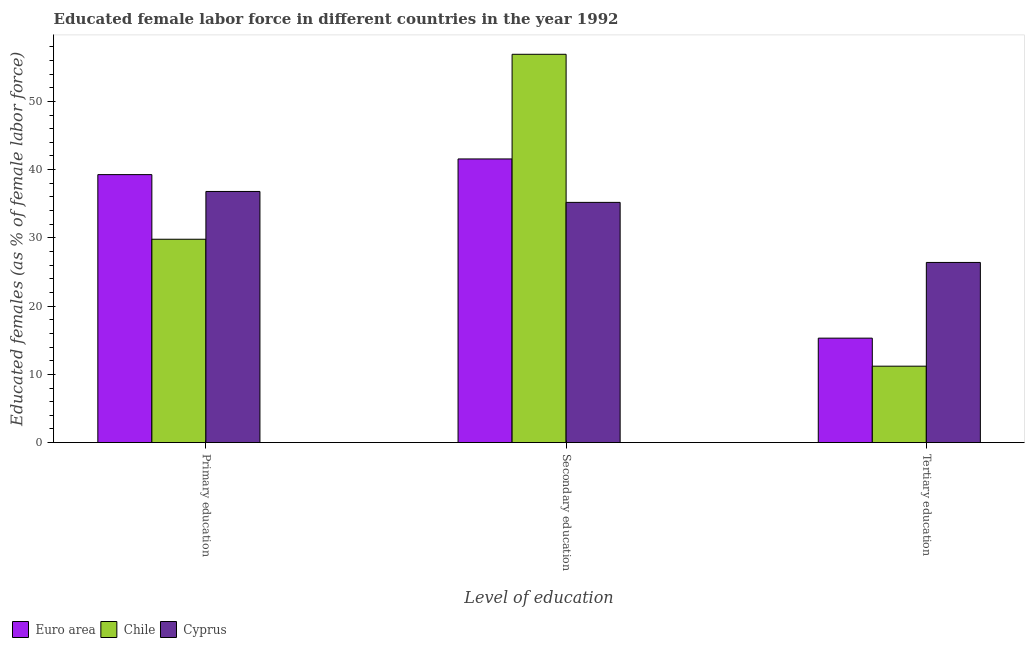How many different coloured bars are there?
Make the answer very short. 3. How many groups of bars are there?
Your answer should be compact. 3. Are the number of bars on each tick of the X-axis equal?
Your response must be concise. Yes. What is the label of the 1st group of bars from the left?
Provide a succinct answer. Primary education. What is the percentage of female labor force who received secondary education in Cyprus?
Ensure brevity in your answer.  35.2. Across all countries, what is the maximum percentage of female labor force who received secondary education?
Your answer should be very brief. 56.9. Across all countries, what is the minimum percentage of female labor force who received secondary education?
Provide a succinct answer. 35.2. What is the total percentage of female labor force who received secondary education in the graph?
Keep it short and to the point. 133.66. What is the difference between the percentage of female labor force who received secondary education in Cyprus and that in Chile?
Keep it short and to the point. -21.7. What is the difference between the percentage of female labor force who received secondary education in Cyprus and the percentage of female labor force who received tertiary education in Chile?
Provide a short and direct response. 24. What is the average percentage of female labor force who received tertiary education per country?
Your answer should be compact. 17.64. What is the difference between the percentage of female labor force who received primary education and percentage of female labor force who received secondary education in Cyprus?
Offer a terse response. 1.6. In how many countries, is the percentage of female labor force who received tertiary education greater than 12 %?
Provide a succinct answer. 2. What is the ratio of the percentage of female labor force who received secondary education in Euro area to that in Cyprus?
Keep it short and to the point. 1.18. Is the percentage of female labor force who received secondary education in Cyprus less than that in Euro area?
Your answer should be very brief. Yes. What is the difference between the highest and the second highest percentage of female labor force who received primary education?
Keep it short and to the point. 2.47. What is the difference between the highest and the lowest percentage of female labor force who received tertiary education?
Offer a very short reply. 15.2. In how many countries, is the percentage of female labor force who received tertiary education greater than the average percentage of female labor force who received tertiary education taken over all countries?
Your response must be concise. 1. What does the 3rd bar from the right in Tertiary education represents?
Provide a short and direct response. Euro area. How many bars are there?
Offer a terse response. 9. How many countries are there in the graph?
Ensure brevity in your answer.  3. What is the difference between two consecutive major ticks on the Y-axis?
Provide a succinct answer. 10. Does the graph contain grids?
Provide a short and direct response. No. How are the legend labels stacked?
Give a very brief answer. Horizontal. What is the title of the graph?
Give a very brief answer. Educated female labor force in different countries in the year 1992. Does "Bosnia and Herzegovina" appear as one of the legend labels in the graph?
Give a very brief answer. No. What is the label or title of the X-axis?
Give a very brief answer. Level of education. What is the label or title of the Y-axis?
Give a very brief answer. Educated females (as % of female labor force). What is the Educated females (as % of female labor force) in Euro area in Primary education?
Your response must be concise. 39.27. What is the Educated females (as % of female labor force) in Chile in Primary education?
Make the answer very short. 29.8. What is the Educated females (as % of female labor force) in Cyprus in Primary education?
Offer a terse response. 36.8. What is the Educated females (as % of female labor force) of Euro area in Secondary education?
Give a very brief answer. 41.56. What is the Educated females (as % of female labor force) of Chile in Secondary education?
Offer a very short reply. 56.9. What is the Educated females (as % of female labor force) of Cyprus in Secondary education?
Give a very brief answer. 35.2. What is the Educated females (as % of female labor force) of Euro area in Tertiary education?
Your answer should be compact. 15.31. What is the Educated females (as % of female labor force) in Chile in Tertiary education?
Your answer should be very brief. 11.2. What is the Educated females (as % of female labor force) of Cyprus in Tertiary education?
Your response must be concise. 26.4. Across all Level of education, what is the maximum Educated females (as % of female labor force) of Euro area?
Your answer should be compact. 41.56. Across all Level of education, what is the maximum Educated females (as % of female labor force) of Chile?
Make the answer very short. 56.9. Across all Level of education, what is the maximum Educated females (as % of female labor force) of Cyprus?
Ensure brevity in your answer.  36.8. Across all Level of education, what is the minimum Educated females (as % of female labor force) of Euro area?
Provide a succinct answer. 15.31. Across all Level of education, what is the minimum Educated females (as % of female labor force) in Chile?
Your response must be concise. 11.2. Across all Level of education, what is the minimum Educated females (as % of female labor force) in Cyprus?
Make the answer very short. 26.4. What is the total Educated females (as % of female labor force) in Euro area in the graph?
Provide a short and direct response. 96.14. What is the total Educated females (as % of female labor force) in Chile in the graph?
Provide a short and direct response. 97.9. What is the total Educated females (as % of female labor force) in Cyprus in the graph?
Provide a short and direct response. 98.4. What is the difference between the Educated females (as % of female labor force) of Euro area in Primary education and that in Secondary education?
Your answer should be compact. -2.3. What is the difference between the Educated females (as % of female labor force) of Chile in Primary education and that in Secondary education?
Your response must be concise. -27.1. What is the difference between the Educated females (as % of female labor force) in Euro area in Primary education and that in Tertiary education?
Ensure brevity in your answer.  23.96. What is the difference between the Educated females (as % of female labor force) in Chile in Primary education and that in Tertiary education?
Your answer should be very brief. 18.6. What is the difference between the Educated females (as % of female labor force) of Euro area in Secondary education and that in Tertiary education?
Provide a succinct answer. 26.26. What is the difference between the Educated females (as % of female labor force) in Chile in Secondary education and that in Tertiary education?
Keep it short and to the point. 45.7. What is the difference between the Educated females (as % of female labor force) in Euro area in Primary education and the Educated females (as % of female labor force) in Chile in Secondary education?
Provide a short and direct response. -17.63. What is the difference between the Educated females (as % of female labor force) of Euro area in Primary education and the Educated females (as % of female labor force) of Cyprus in Secondary education?
Offer a terse response. 4.07. What is the difference between the Educated females (as % of female labor force) in Chile in Primary education and the Educated females (as % of female labor force) in Cyprus in Secondary education?
Give a very brief answer. -5.4. What is the difference between the Educated females (as % of female labor force) of Euro area in Primary education and the Educated females (as % of female labor force) of Chile in Tertiary education?
Provide a succinct answer. 28.07. What is the difference between the Educated females (as % of female labor force) of Euro area in Primary education and the Educated females (as % of female labor force) of Cyprus in Tertiary education?
Your answer should be compact. 12.87. What is the difference between the Educated females (as % of female labor force) of Euro area in Secondary education and the Educated females (as % of female labor force) of Chile in Tertiary education?
Provide a short and direct response. 30.36. What is the difference between the Educated females (as % of female labor force) in Euro area in Secondary education and the Educated females (as % of female labor force) in Cyprus in Tertiary education?
Keep it short and to the point. 15.16. What is the difference between the Educated females (as % of female labor force) of Chile in Secondary education and the Educated females (as % of female labor force) of Cyprus in Tertiary education?
Offer a terse response. 30.5. What is the average Educated females (as % of female labor force) of Euro area per Level of education?
Offer a very short reply. 32.05. What is the average Educated females (as % of female labor force) of Chile per Level of education?
Offer a very short reply. 32.63. What is the average Educated females (as % of female labor force) of Cyprus per Level of education?
Provide a short and direct response. 32.8. What is the difference between the Educated females (as % of female labor force) of Euro area and Educated females (as % of female labor force) of Chile in Primary education?
Offer a terse response. 9.47. What is the difference between the Educated females (as % of female labor force) in Euro area and Educated females (as % of female labor force) in Cyprus in Primary education?
Offer a very short reply. 2.47. What is the difference between the Educated females (as % of female labor force) in Chile and Educated females (as % of female labor force) in Cyprus in Primary education?
Provide a succinct answer. -7. What is the difference between the Educated females (as % of female labor force) of Euro area and Educated females (as % of female labor force) of Chile in Secondary education?
Make the answer very short. -15.34. What is the difference between the Educated females (as % of female labor force) of Euro area and Educated females (as % of female labor force) of Cyprus in Secondary education?
Your answer should be compact. 6.36. What is the difference between the Educated females (as % of female labor force) in Chile and Educated females (as % of female labor force) in Cyprus in Secondary education?
Provide a short and direct response. 21.7. What is the difference between the Educated females (as % of female labor force) of Euro area and Educated females (as % of female labor force) of Chile in Tertiary education?
Make the answer very short. 4.11. What is the difference between the Educated females (as % of female labor force) in Euro area and Educated females (as % of female labor force) in Cyprus in Tertiary education?
Provide a short and direct response. -11.09. What is the difference between the Educated females (as % of female labor force) in Chile and Educated females (as % of female labor force) in Cyprus in Tertiary education?
Your answer should be compact. -15.2. What is the ratio of the Educated females (as % of female labor force) in Euro area in Primary education to that in Secondary education?
Keep it short and to the point. 0.94. What is the ratio of the Educated females (as % of female labor force) in Chile in Primary education to that in Secondary education?
Your answer should be very brief. 0.52. What is the ratio of the Educated females (as % of female labor force) of Cyprus in Primary education to that in Secondary education?
Your answer should be very brief. 1.05. What is the ratio of the Educated females (as % of female labor force) of Euro area in Primary education to that in Tertiary education?
Provide a succinct answer. 2.57. What is the ratio of the Educated females (as % of female labor force) of Chile in Primary education to that in Tertiary education?
Offer a very short reply. 2.66. What is the ratio of the Educated females (as % of female labor force) in Cyprus in Primary education to that in Tertiary education?
Your answer should be very brief. 1.39. What is the ratio of the Educated females (as % of female labor force) of Euro area in Secondary education to that in Tertiary education?
Your answer should be very brief. 2.72. What is the ratio of the Educated females (as % of female labor force) in Chile in Secondary education to that in Tertiary education?
Give a very brief answer. 5.08. What is the ratio of the Educated females (as % of female labor force) of Cyprus in Secondary education to that in Tertiary education?
Offer a terse response. 1.33. What is the difference between the highest and the second highest Educated females (as % of female labor force) of Euro area?
Your answer should be very brief. 2.3. What is the difference between the highest and the second highest Educated females (as % of female labor force) in Chile?
Give a very brief answer. 27.1. What is the difference between the highest and the second highest Educated females (as % of female labor force) in Cyprus?
Your response must be concise. 1.6. What is the difference between the highest and the lowest Educated females (as % of female labor force) of Euro area?
Provide a succinct answer. 26.26. What is the difference between the highest and the lowest Educated females (as % of female labor force) in Chile?
Make the answer very short. 45.7. 